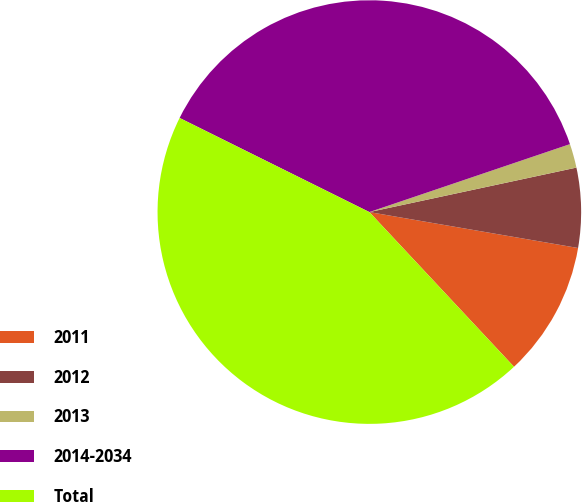Convert chart to OTSL. <chart><loc_0><loc_0><loc_500><loc_500><pie_chart><fcel>2011<fcel>2012<fcel>2013<fcel>2014-2034<fcel>Total<nl><fcel>10.32%<fcel>6.08%<fcel>1.83%<fcel>37.47%<fcel>44.29%<nl></chart> 